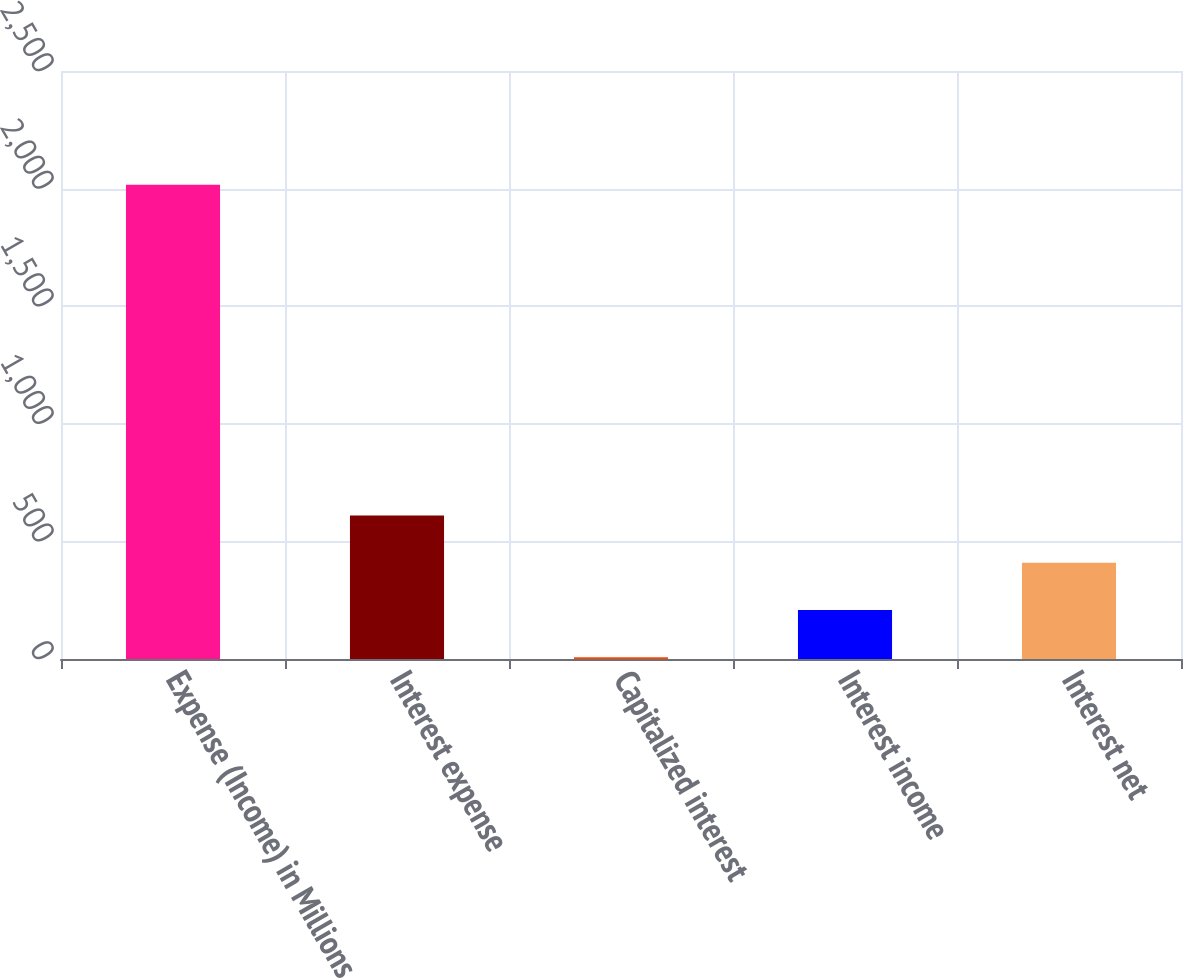Convert chart. <chart><loc_0><loc_0><loc_500><loc_500><bar_chart><fcel>Expense (Income) in Millions<fcel>Interest expense<fcel>Capitalized interest<fcel>Interest income<fcel>Interest net<nl><fcel>2016<fcel>610.19<fcel>7.7<fcel>208.53<fcel>409.36<nl></chart> 